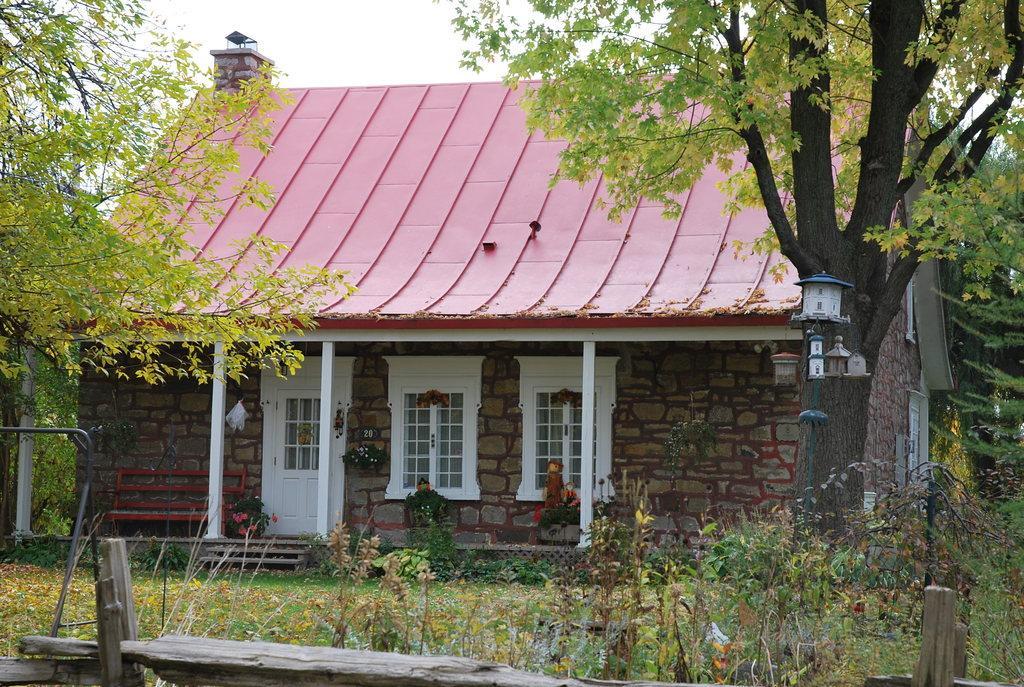How would you summarize this image in a sentence or two? In this picture there is a house with white windows and rooftop. In the front bottom side there is a green plants in the ground. On the right corner there is a tree. 